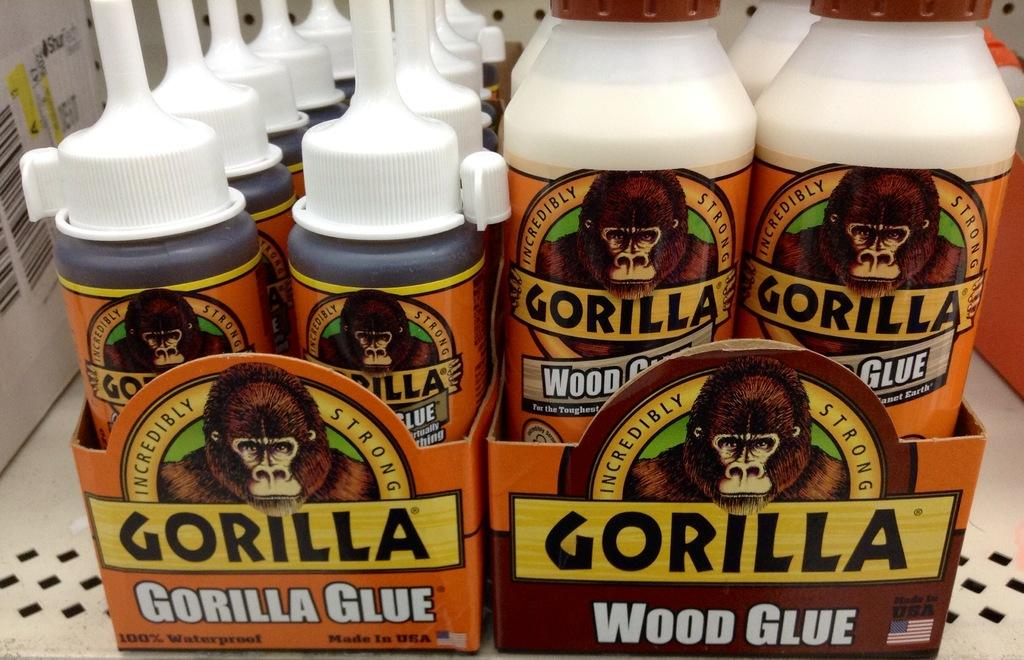What type of bottles are present in the image? There are wood glue glue bottles in the image. Can you describe the contents of the bottles? The bottles contain wood glue. How many bottles are visible in the image? The number of bottles is not specified, but there are wood glue bottles present in the image. How many houses are visible in the image? There are no houses present in the image; it only features wood glue bottles. What type of bag is shown holding the wood glue bottles in the image? There is no bag present in the image; the wood glue bottles are not contained within a bag. 